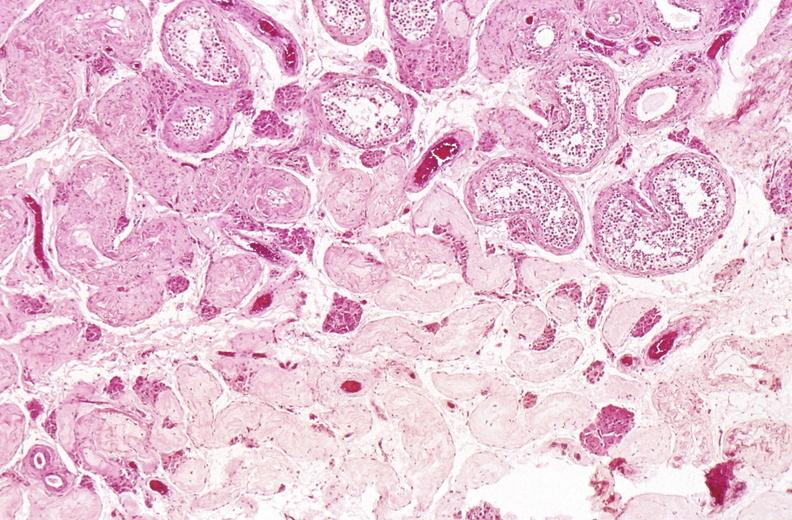does this image show testes, testicular atrophy?
Answer the question using a single word or phrase. Yes 